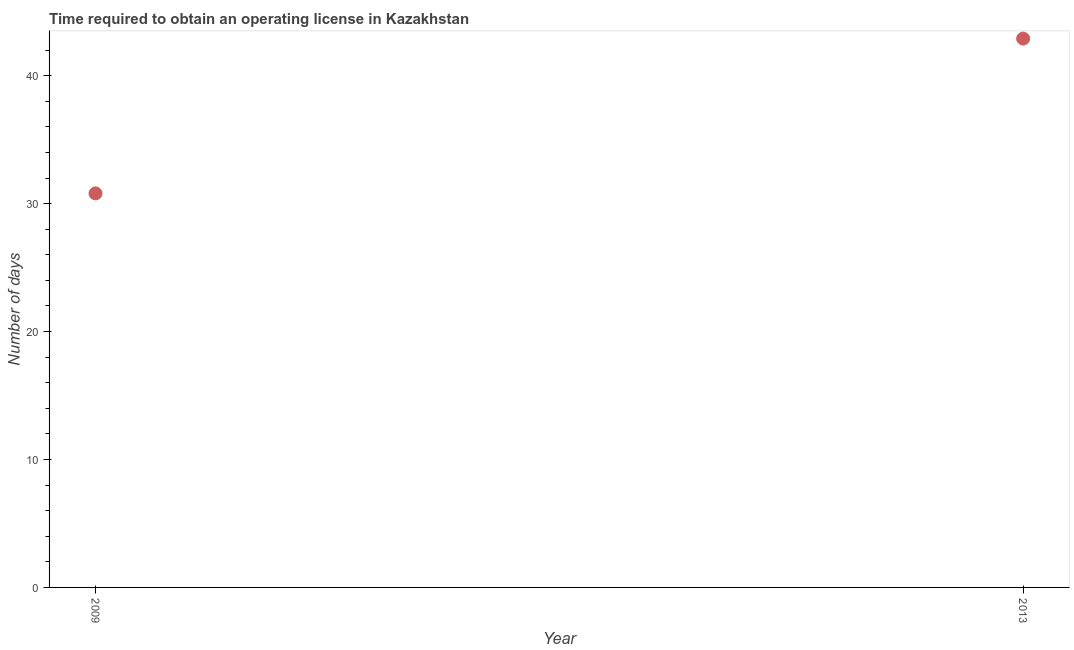What is the number of days to obtain operating license in 2009?
Make the answer very short. 30.8. Across all years, what is the maximum number of days to obtain operating license?
Offer a very short reply. 42.9. Across all years, what is the minimum number of days to obtain operating license?
Ensure brevity in your answer.  30.8. In which year was the number of days to obtain operating license maximum?
Ensure brevity in your answer.  2013. In which year was the number of days to obtain operating license minimum?
Keep it short and to the point. 2009. What is the sum of the number of days to obtain operating license?
Your answer should be very brief. 73.7. What is the difference between the number of days to obtain operating license in 2009 and 2013?
Ensure brevity in your answer.  -12.1. What is the average number of days to obtain operating license per year?
Give a very brief answer. 36.85. What is the median number of days to obtain operating license?
Offer a terse response. 36.85. Do a majority of the years between 2009 and 2013 (inclusive) have number of days to obtain operating license greater than 40 days?
Offer a very short reply. No. What is the ratio of the number of days to obtain operating license in 2009 to that in 2013?
Your answer should be very brief. 0.72. Is the number of days to obtain operating license in 2009 less than that in 2013?
Provide a succinct answer. Yes. Are the values on the major ticks of Y-axis written in scientific E-notation?
Your response must be concise. No. Does the graph contain any zero values?
Provide a succinct answer. No. What is the title of the graph?
Your response must be concise. Time required to obtain an operating license in Kazakhstan. What is the label or title of the X-axis?
Your answer should be very brief. Year. What is the label or title of the Y-axis?
Provide a succinct answer. Number of days. What is the Number of days in 2009?
Your response must be concise. 30.8. What is the Number of days in 2013?
Provide a succinct answer. 42.9. What is the difference between the Number of days in 2009 and 2013?
Make the answer very short. -12.1. What is the ratio of the Number of days in 2009 to that in 2013?
Keep it short and to the point. 0.72. 